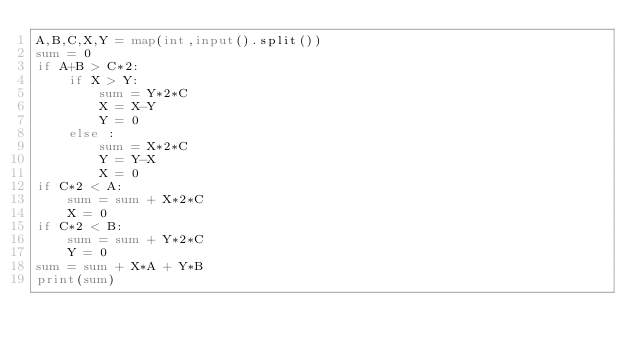<code> <loc_0><loc_0><loc_500><loc_500><_Python_>A,B,C,X,Y = map(int,input().split())
sum = 0
if A+B > C*2:
    if X > Y:
        sum = Y*2*C
        X = X-Y
        Y = 0
    else :
        sum = X*2*C
        Y = Y-X
        X = 0
if C*2 < A:
    sum = sum + X*2*C
    X = 0
if C*2 < B:
    sum = sum + Y*2*C
    Y = 0
sum = sum + X*A + Y*B
print(sum)</code> 